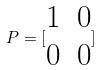Convert formula to latex. <formula><loc_0><loc_0><loc_500><loc_500>P = [ \begin{matrix} 1 & 0 \\ 0 & 0 \end{matrix} ]</formula> 